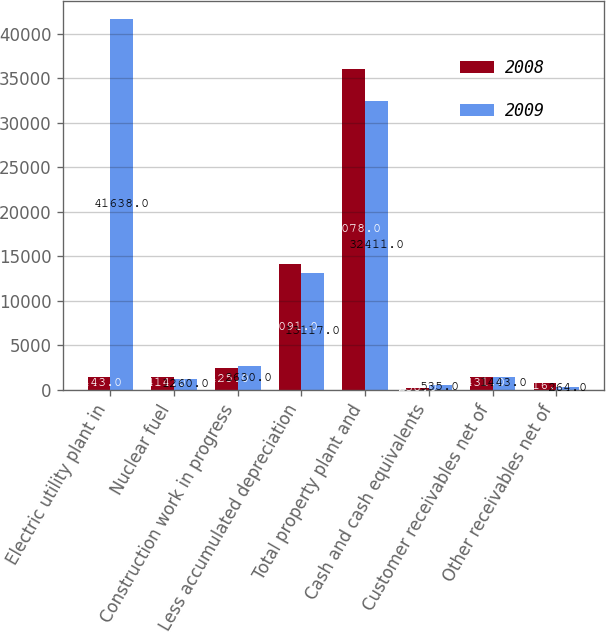<chart> <loc_0><loc_0><loc_500><loc_500><stacked_bar_chart><ecel><fcel>Electric utility plant in<fcel>Nuclear fuel<fcel>Construction work in progress<fcel>Less accumulated depreciation<fcel>Total property plant and<fcel>Cash and cash equivalents<fcel>Customer receivables net of<fcel>Other receivables net of<nl><fcel>2008<fcel>1443<fcel>1414<fcel>2425<fcel>14091<fcel>36078<fcel>238<fcel>1431<fcel>816<nl><fcel>2009<fcel>41638<fcel>1260<fcel>2630<fcel>13117<fcel>32411<fcel>535<fcel>1443<fcel>264<nl></chart> 